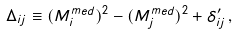Convert formula to latex. <formula><loc_0><loc_0><loc_500><loc_500>\Delta _ { i j } \equiv ( M _ { i } ^ { m e d } ) ^ { 2 } - ( M _ { j } ^ { m e d } ) ^ { 2 } + \delta _ { i j } ^ { \prime } \, ,</formula> 